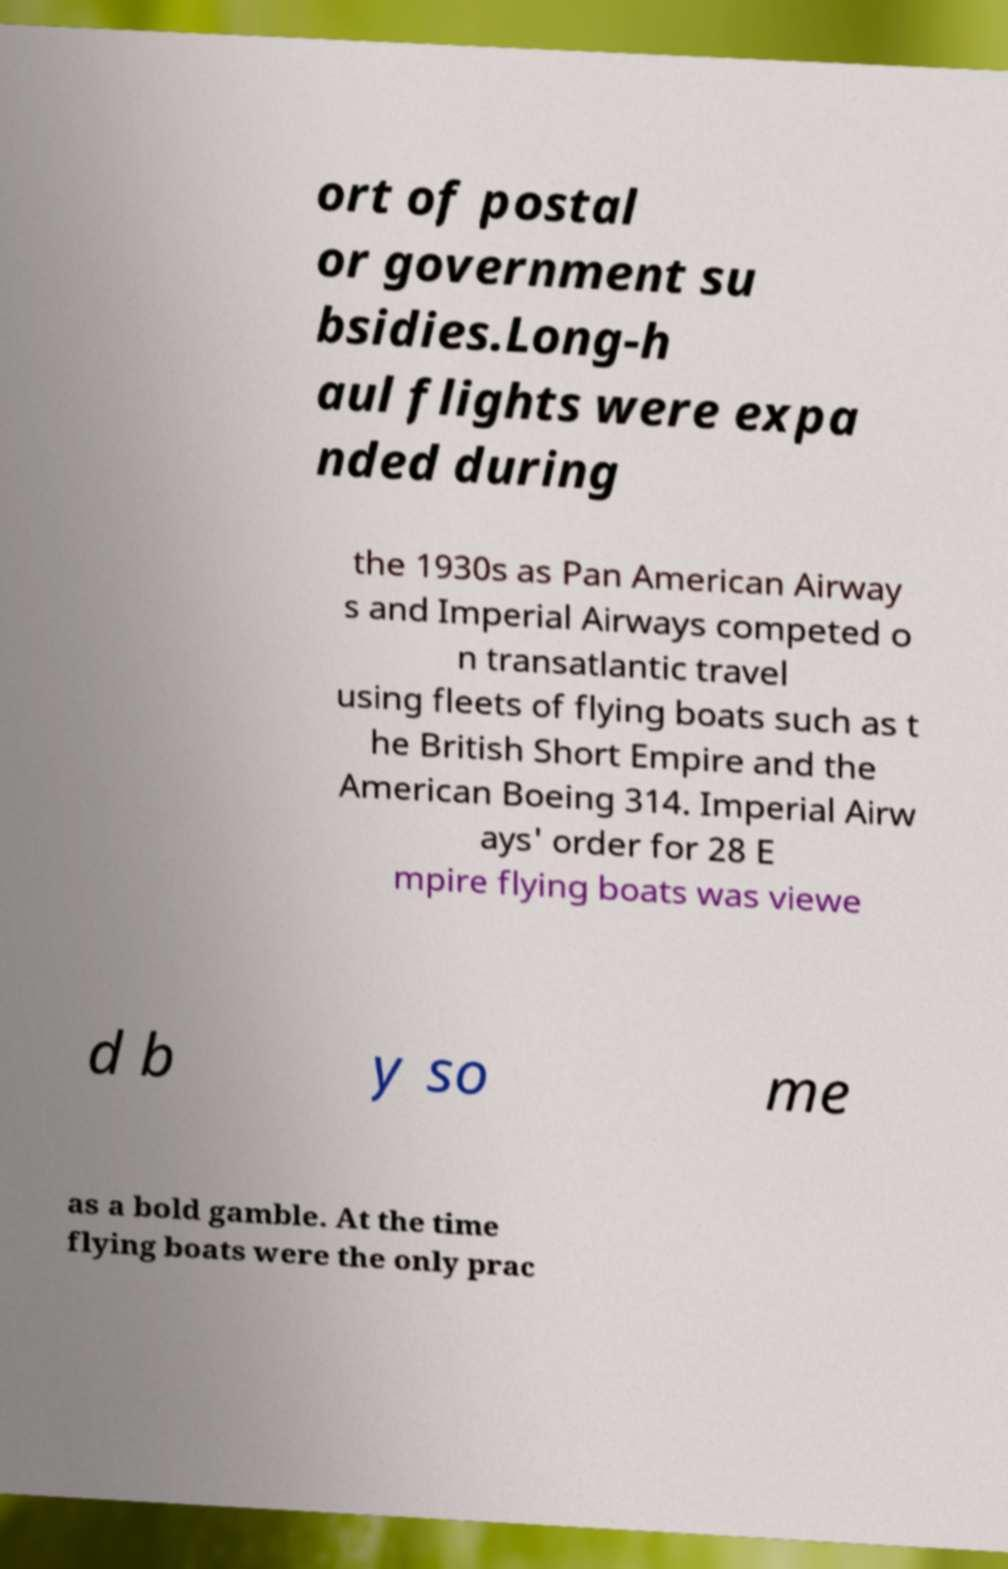Please read and relay the text visible in this image. What does it say? ort of postal or government su bsidies.Long-h aul flights were expa nded during the 1930s as Pan American Airway s and Imperial Airways competed o n transatlantic travel using fleets of flying boats such as t he British Short Empire and the American Boeing 314. Imperial Airw ays' order for 28 E mpire flying boats was viewe d b y so me as a bold gamble. At the time flying boats were the only prac 